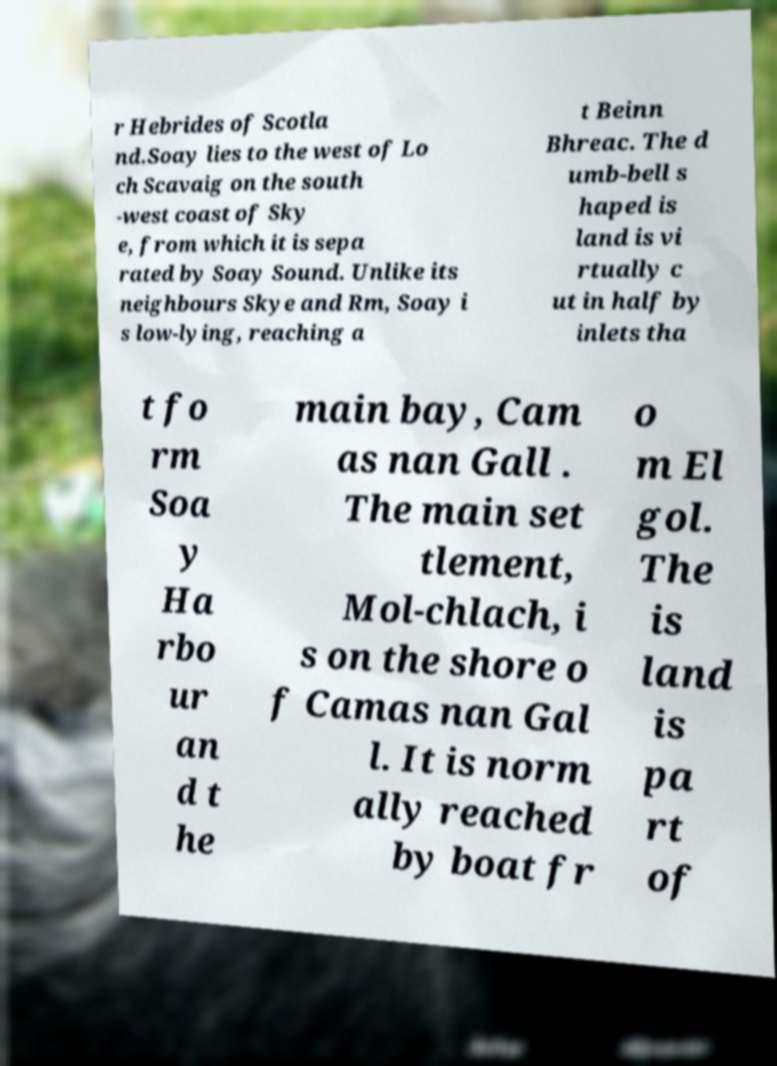I need the written content from this picture converted into text. Can you do that? r Hebrides of Scotla nd.Soay lies to the west of Lo ch Scavaig on the south -west coast of Sky e, from which it is sepa rated by Soay Sound. Unlike its neighbours Skye and Rm, Soay i s low-lying, reaching a t Beinn Bhreac. The d umb-bell s haped is land is vi rtually c ut in half by inlets tha t fo rm Soa y Ha rbo ur an d t he main bay, Cam as nan Gall . The main set tlement, Mol-chlach, i s on the shore o f Camas nan Gal l. It is norm ally reached by boat fr o m El gol. The is land is pa rt of 